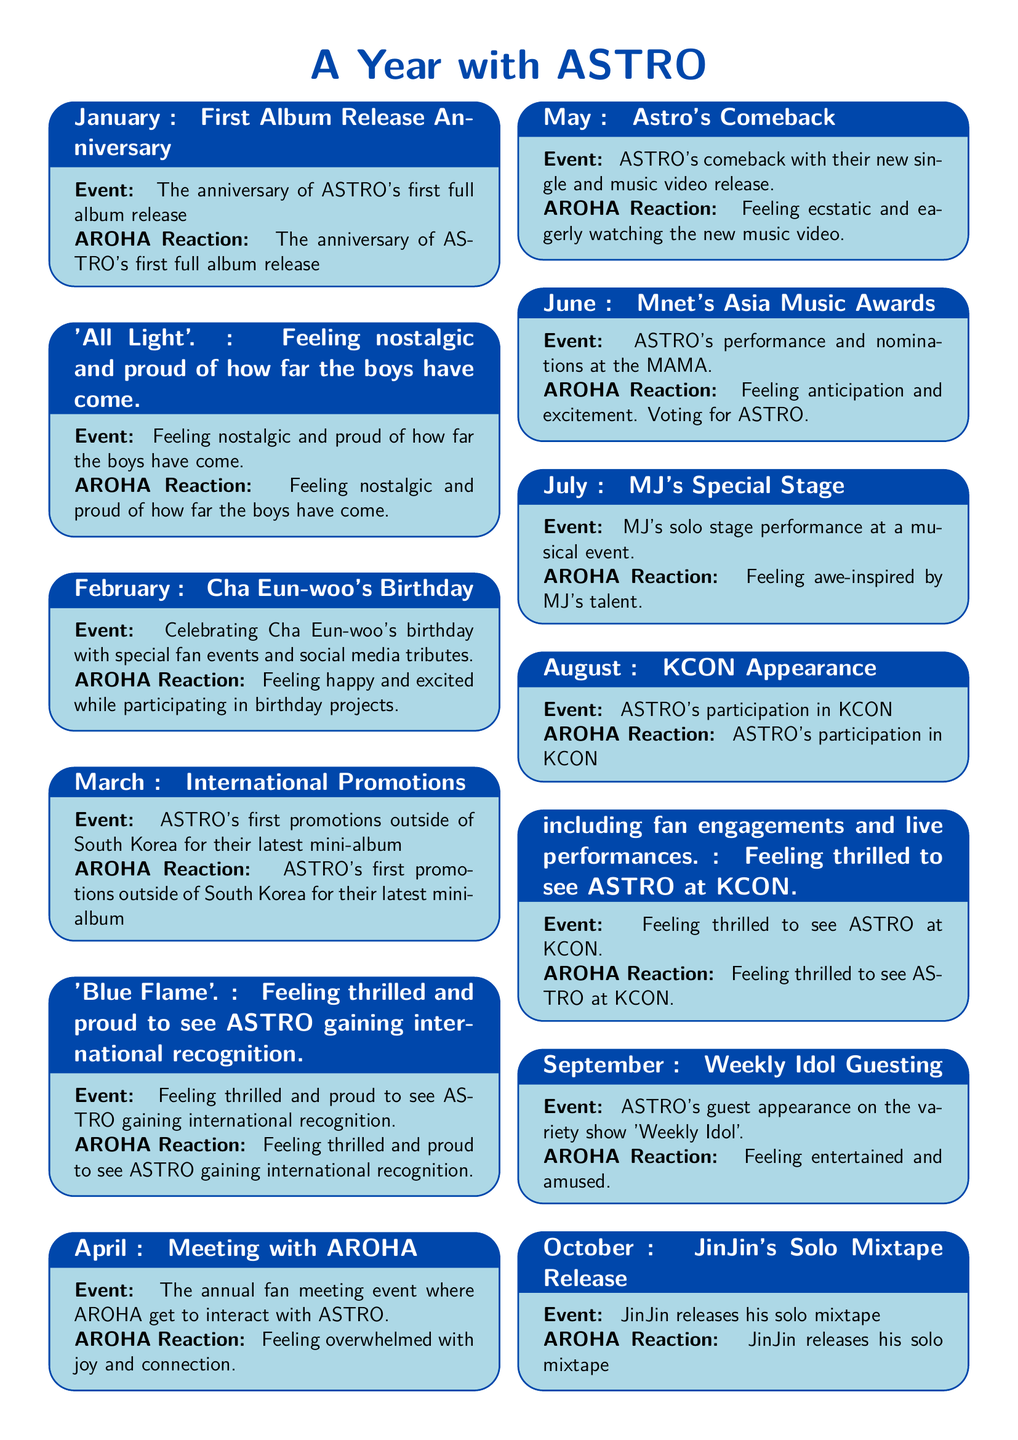what is the first event mentioned? The first event listed in the document is ASTRO's first album release anniversary in January.
Answer: First Album Release Anniversary which month celebrates Cha Eun-woo's birthday? The document states that Cha Eun-woo's birthday is celebrated in February.
Answer: February how did AROHA feel about the end-of-year concert? The document describes AROHA's reaction to feeling celebratory and joyful regarding the end-of-year concert.
Answer: celebratory and joyful what significant event occurred in March? In March, ASTRO had international promotions for their mini-album 'Blue Flame'.
Answer: International Promotions how many events are listed in the document? The total number of events is determined by counting each entry month from January to December, which totals 12 events.
Answer: 12 what was JinJin's contribution in October? JinJin released his solo mixtape, showcasing his personal music style.
Answer: solo mixtape release what was AROHA's reaction to the Mnet's Asia Music Awards in June? AROHA felt anticipation and excitement during Mnet's Asia Music Awards.
Answer: anticipation and excitement which event took place in July? The event in July was MJ's special stage performance at a musical event.
Answer: MJ's Special Stage what does the document highlight in terms of emotional reactions? The document highlights the emotional journey of AROHA throughout the year as they reacted to various ASTRO events.
Answer: emotional journey of AROHA 